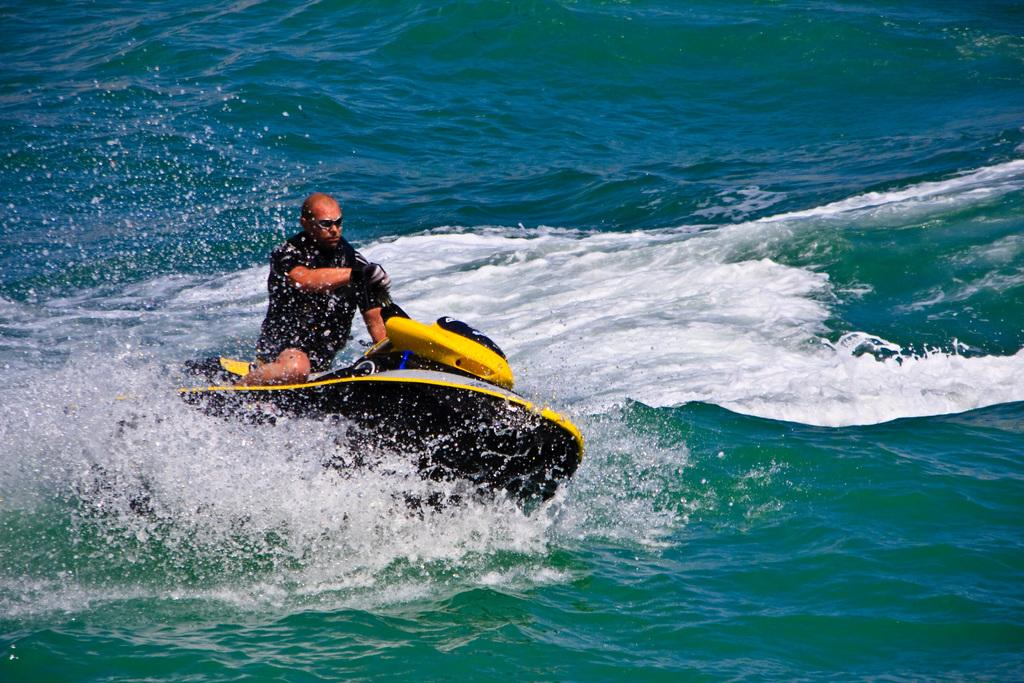What is the main subject of the image? The main subject of the image is a man. What is the man doing in the image? The man is riding a boat in the image. Where is the boat located in the image? The boat is in the center of the image. What can be seen in the background of the image? There is water visible in the background of the image. Can you see a crow flying in a circle above the man in the image? There is no crow present in the image, and therefore no such activity can be observed. 